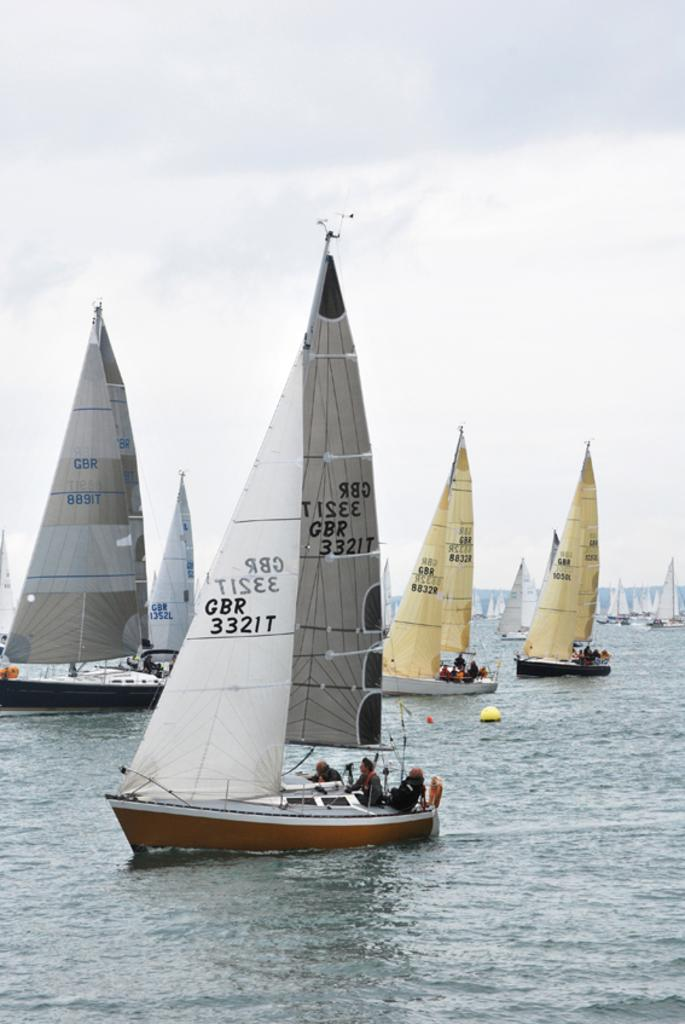<image>
Render a clear and concise summary of the photo. several sailboats are on the sea, onw marked GBR 3321T 